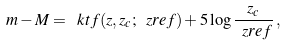<formula> <loc_0><loc_0><loc_500><loc_500>m - M = \ k t f ( z , z _ { c } ; \ z r e f ) + 5 \log \frac { z _ { c } } { \ z r e f } \, ,</formula> 